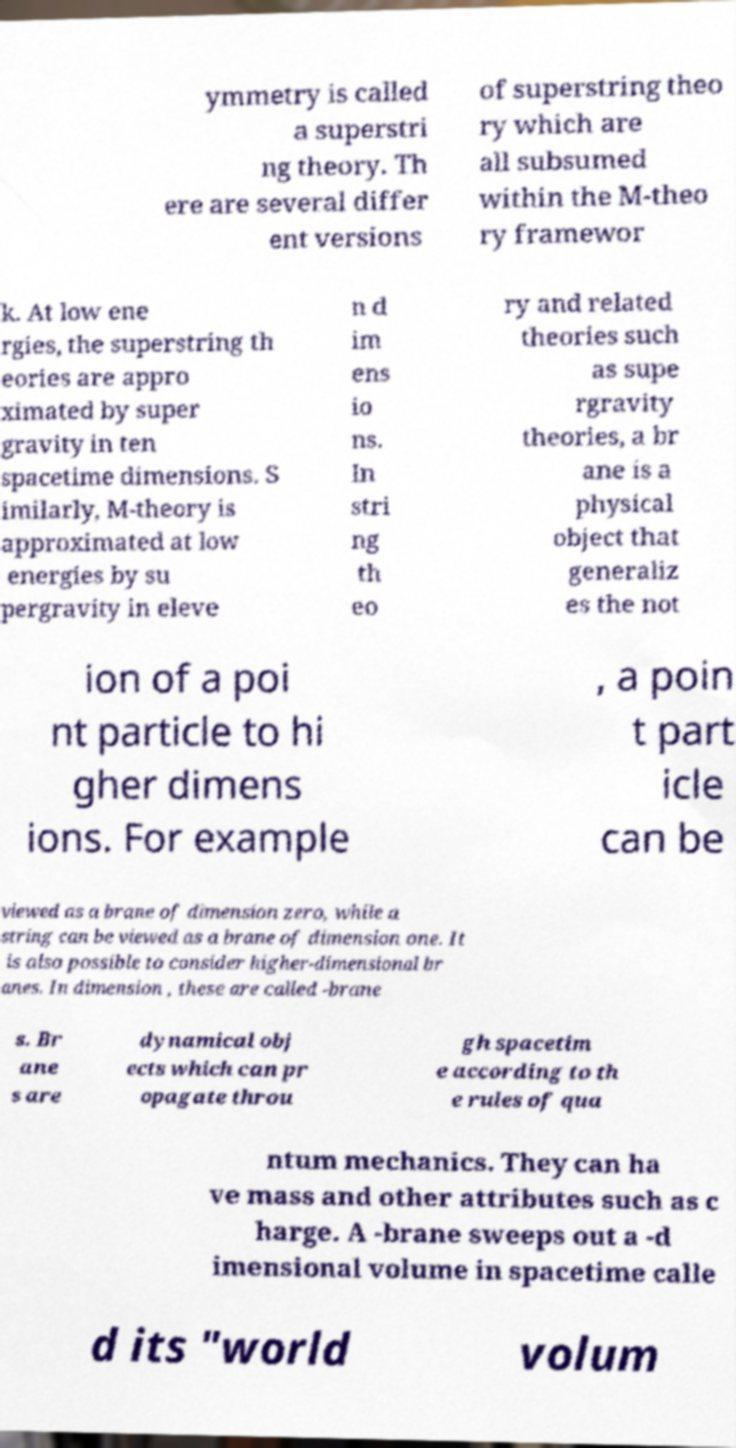Please read and relay the text visible in this image. What does it say? ymmetry is called a superstri ng theory. Th ere are several differ ent versions of superstring theo ry which are all subsumed within the M-theo ry framewor k. At low ene rgies, the superstring th eories are appro ximated by super gravity in ten spacetime dimensions. S imilarly, M-theory is approximated at low energies by su pergravity in eleve n d im ens io ns. In stri ng th eo ry and related theories such as supe rgravity theories, a br ane is a physical object that generaliz es the not ion of a poi nt particle to hi gher dimens ions. For example , a poin t part icle can be viewed as a brane of dimension zero, while a string can be viewed as a brane of dimension one. It is also possible to consider higher-dimensional br anes. In dimension , these are called -brane s. Br ane s are dynamical obj ects which can pr opagate throu gh spacetim e according to th e rules of qua ntum mechanics. They can ha ve mass and other attributes such as c harge. A -brane sweeps out a -d imensional volume in spacetime calle d its "world volum 